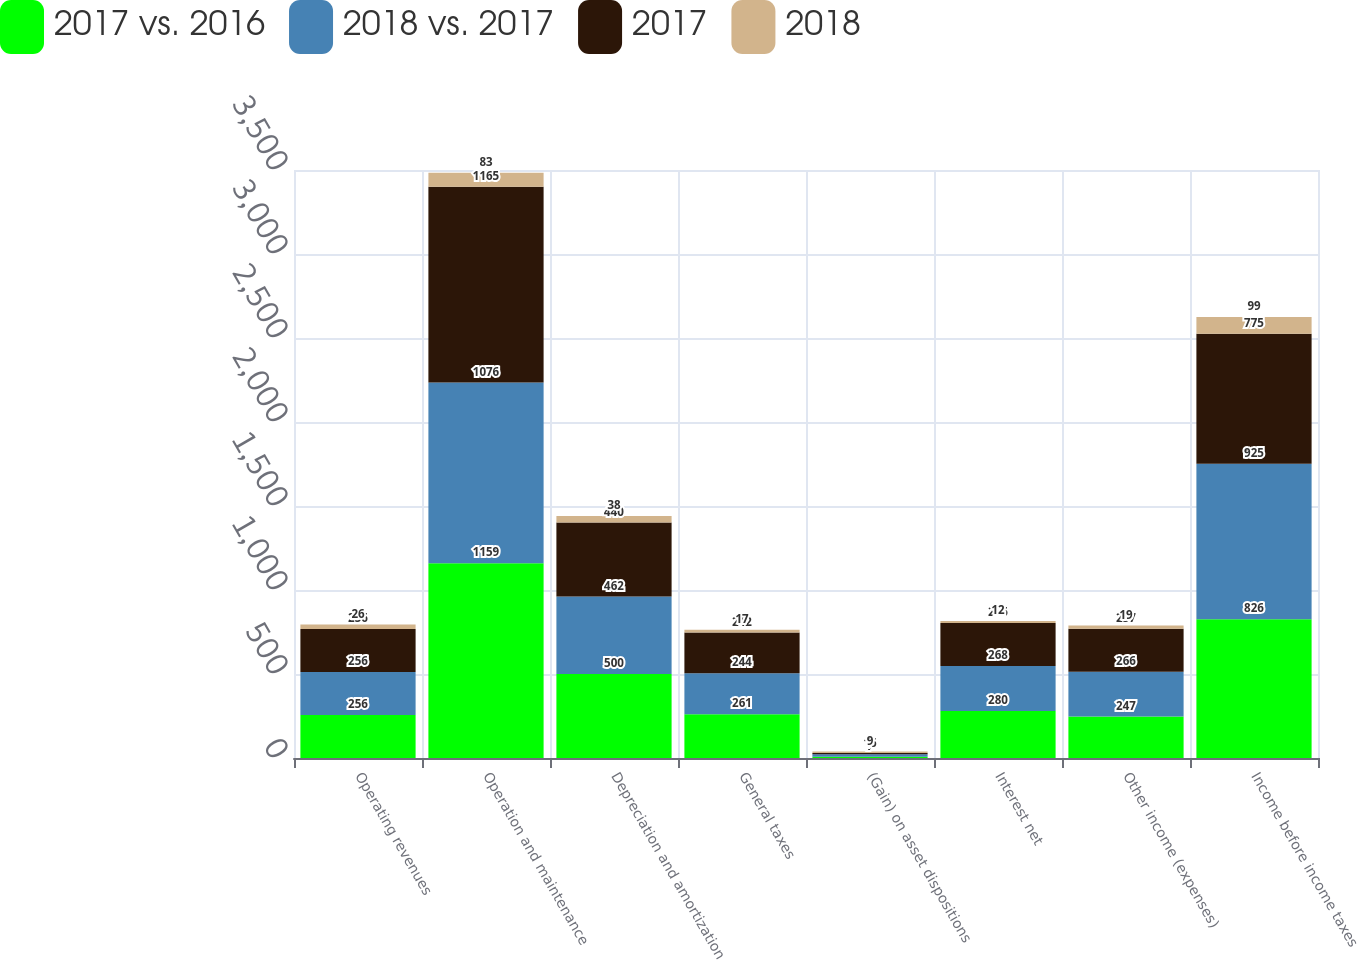<chart> <loc_0><loc_0><loc_500><loc_500><stacked_bar_chart><ecel><fcel>Operating revenues<fcel>Operation and maintenance<fcel>Depreciation and amortization<fcel>General taxes<fcel>(Gain) on asset dispositions<fcel>Interest net<fcel>Other income (expenses)<fcel>Income before income taxes<nl><fcel>2017 vs. 2016<fcel>256<fcel>1159<fcel>500<fcel>261<fcel>7<fcel>280<fcel>247<fcel>826<nl><fcel>2018 vs. 2017<fcel>256<fcel>1076<fcel>462<fcel>244<fcel>16<fcel>268<fcel>266<fcel>925<nl><fcel>2017<fcel>256<fcel>1165<fcel>440<fcel>242<fcel>7<fcel>256<fcel>257<fcel>775<nl><fcel>2018<fcel>26<fcel>83<fcel>38<fcel>17<fcel>9<fcel>12<fcel>19<fcel>99<nl></chart> 